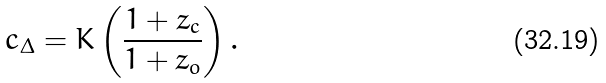Convert formula to latex. <formula><loc_0><loc_0><loc_500><loc_500>c _ { \Delta } = K \left ( \frac { 1 + z _ { c } } { 1 + z _ { o } } \right ) .</formula> 